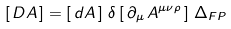<formula> <loc_0><loc_0><loc_500><loc_500>\left [ \, D A \, \right ] = \left [ \, d A \, \right ] \, \delta \left [ \, \partial _ { \mu } \, A ^ { \mu \nu \rho } \, \right ] \, \Delta _ { F P }</formula> 